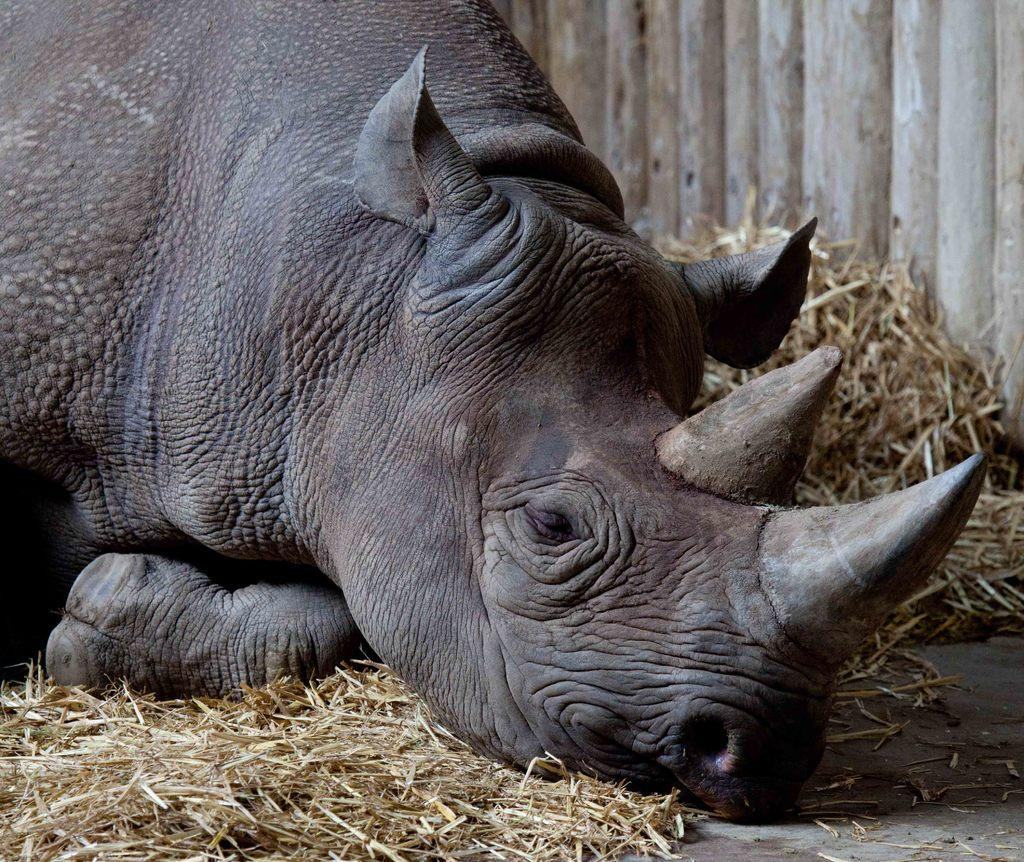What animal is the main subject of the image? There is a hippopotamus in the image. What is the hippopotamus doing in the image? The hippopotamus is laying on dry grass. What type of kitty can be seen playing with a picture in the image? There is no kitty or picture present in the image; it features a hippopotamus laying on dry grass. Is there a lawyer present in the image? There is no mention of a lawyer in the image, which only features a hippopotamus laying on dry grass. 